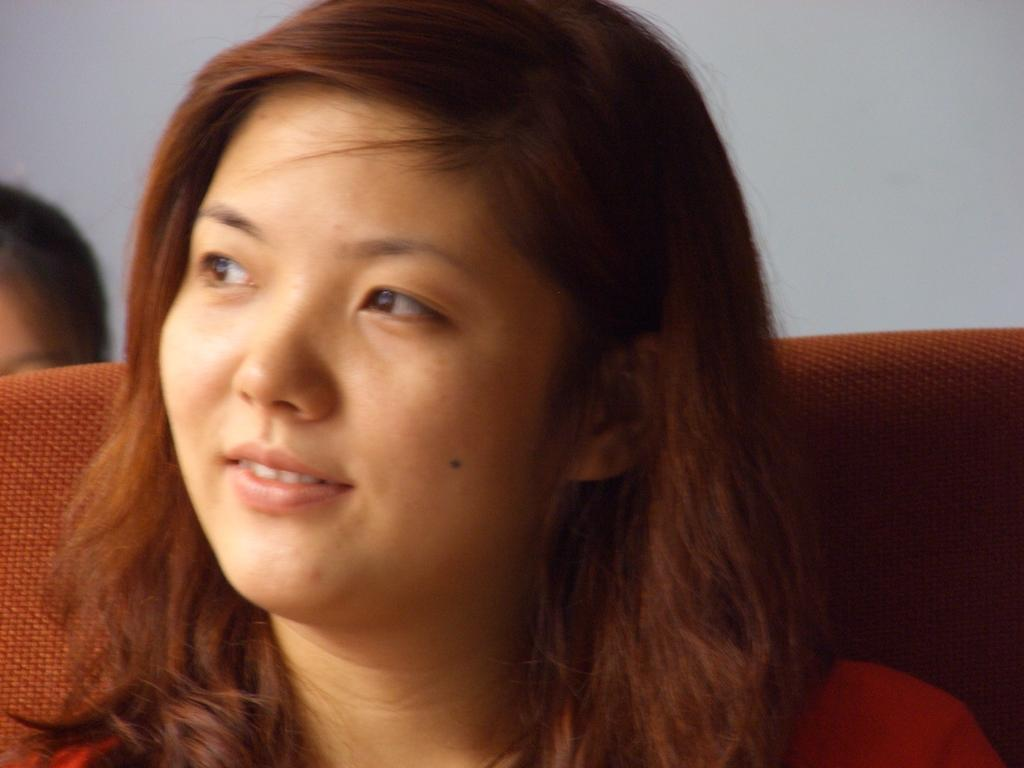Who is present in the image? There is a person in the image. What is the person wearing? The person is wearing a red shirt. Can you describe the background of the image? There is another person in the background of the image, and the wall is white. What type of leaf can be seen falling in the image? There is no leaf present in the image. What impulse might the person in the image be experiencing? We cannot determine the person's emotions or impulses from the image alone. 